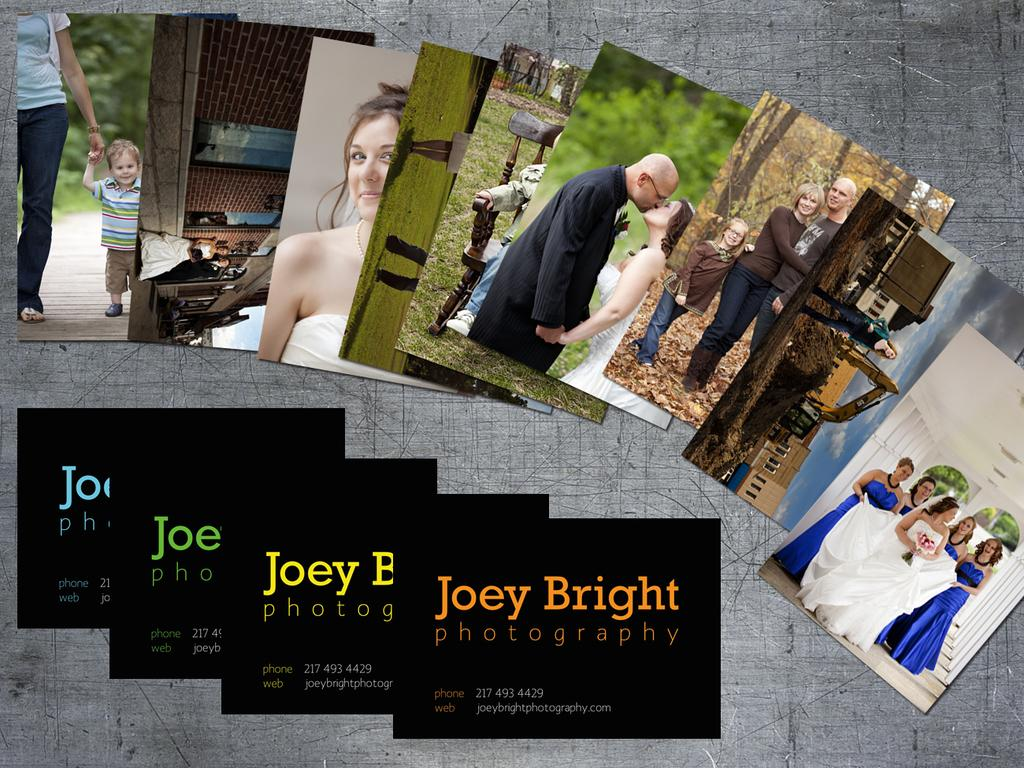What is depicted in the image? There are pictures of persons in the image. What is featured on the pictures of persons? There is writing on the pictures of persons. What type of payment method is being used in the image? There is no payment method present in the image; it only features pictures of persons with writing on them. Can you see any ducks in the image? There are no ducks present in the image. What riddle can be solved by looking at the pictures of persons in the image? There is no riddle present in the image; it only features pictures of persons with writing on them. 